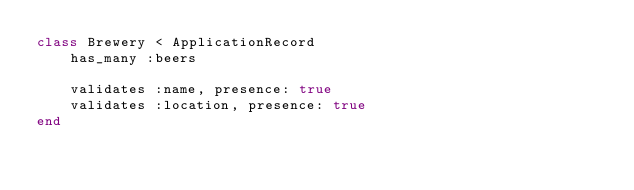Convert code to text. <code><loc_0><loc_0><loc_500><loc_500><_Ruby_>class Brewery < ApplicationRecord
    has_many :beers

    validates :name, presence: true
    validates :location, presence: true
end</code> 